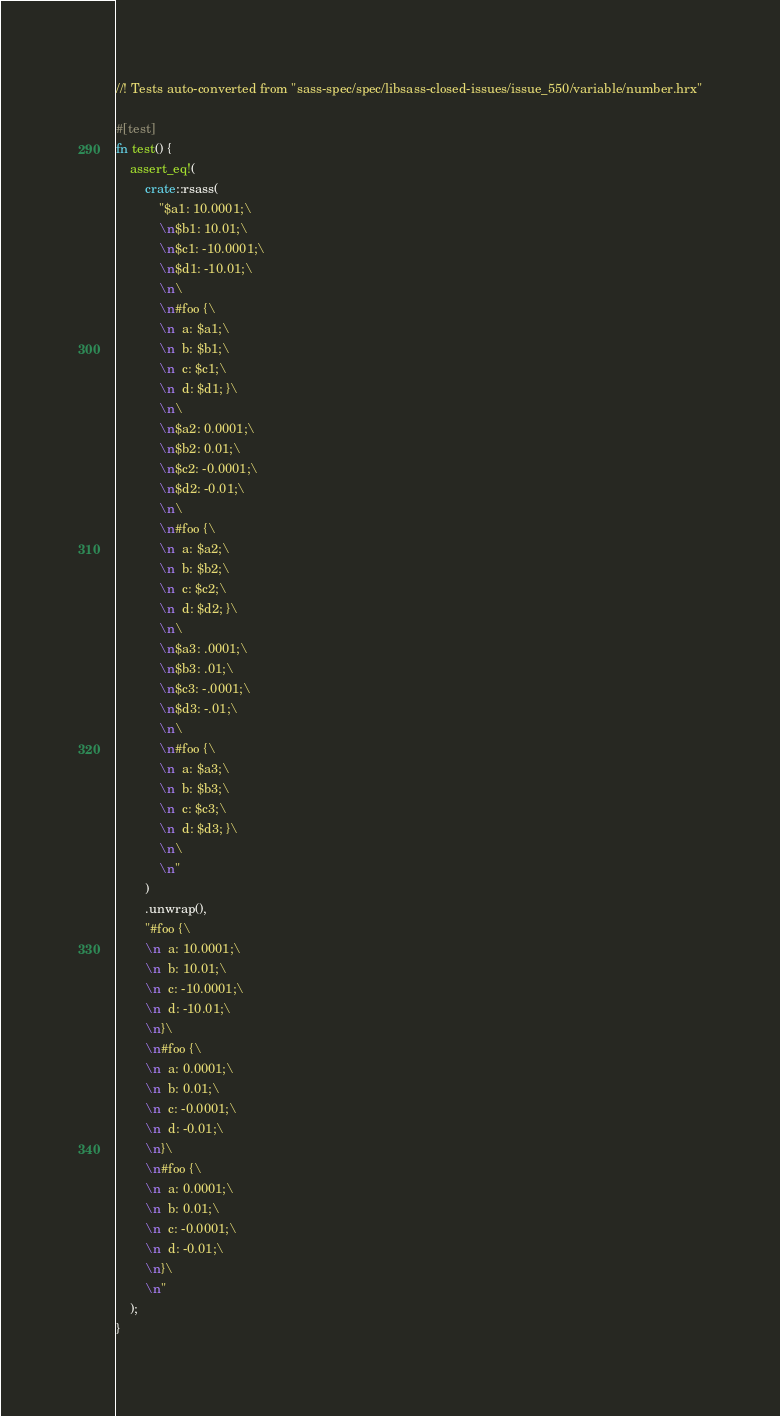<code> <loc_0><loc_0><loc_500><loc_500><_Rust_>//! Tests auto-converted from "sass-spec/spec/libsass-closed-issues/issue_550/variable/number.hrx"

#[test]
fn test() {
    assert_eq!(
        crate::rsass(
            "$a1: 10.0001;\
            \n$b1: 10.01;\
            \n$c1: -10.0001;\
            \n$d1: -10.01;\
            \n\
            \n#foo {\
            \n  a: $a1;\
            \n  b: $b1;\
            \n  c: $c1;\
            \n  d: $d1; }\
            \n\
            \n$a2: 0.0001;\
            \n$b2: 0.01;\
            \n$c2: -0.0001;\
            \n$d2: -0.01;\
            \n\
            \n#foo {\
            \n  a: $a2;\
            \n  b: $b2;\
            \n  c: $c2;\
            \n  d: $d2; }\
            \n\
            \n$a3: .0001;\
            \n$b3: .01;\
            \n$c3: -.0001;\
            \n$d3: -.01;\
            \n\
            \n#foo {\
            \n  a: $a3;\
            \n  b: $b3;\
            \n  c: $c3;\
            \n  d: $d3; }\
            \n\
            \n"
        )
        .unwrap(),
        "#foo {\
        \n  a: 10.0001;\
        \n  b: 10.01;\
        \n  c: -10.0001;\
        \n  d: -10.01;\
        \n}\
        \n#foo {\
        \n  a: 0.0001;\
        \n  b: 0.01;\
        \n  c: -0.0001;\
        \n  d: -0.01;\
        \n}\
        \n#foo {\
        \n  a: 0.0001;\
        \n  b: 0.01;\
        \n  c: -0.0001;\
        \n  d: -0.01;\
        \n}\
        \n"
    );
}
</code> 